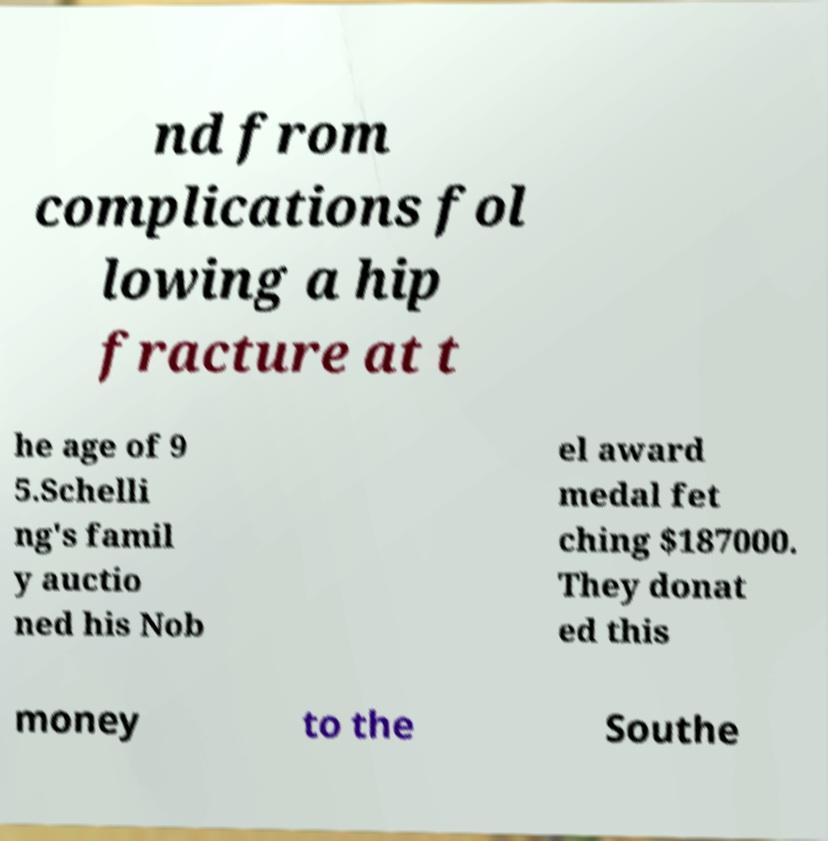Could you extract and type out the text from this image? nd from complications fol lowing a hip fracture at t he age of 9 5.Schelli ng's famil y auctio ned his Nob el award medal fet ching $187000. They donat ed this money to the Southe 